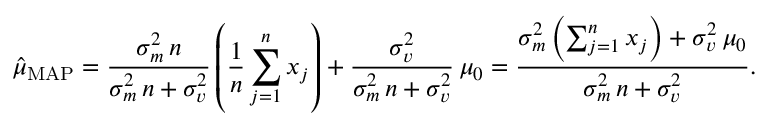<formula> <loc_0><loc_0><loc_500><loc_500>{ \hat { \mu } } _ { M A P } = { \frac { \sigma _ { m } ^ { 2 } \, n } { \sigma _ { m } ^ { 2 } \, n + \sigma _ { v } ^ { 2 } } } \left ( { \frac { 1 } { n } } \sum _ { j = 1 } ^ { n } x _ { j } \right ) + { \frac { \sigma _ { v } ^ { 2 } } { \sigma _ { m } ^ { 2 } \, n + \sigma _ { v } ^ { 2 } } } \, \mu _ { 0 } = { \frac { \sigma _ { m } ^ { 2 } \left ( \sum _ { j = 1 } ^ { n } x _ { j } \right ) + \sigma _ { v } ^ { 2 } \, \mu _ { 0 } } { \sigma _ { m } ^ { 2 } \, n + \sigma _ { v } ^ { 2 } } } .</formula> 